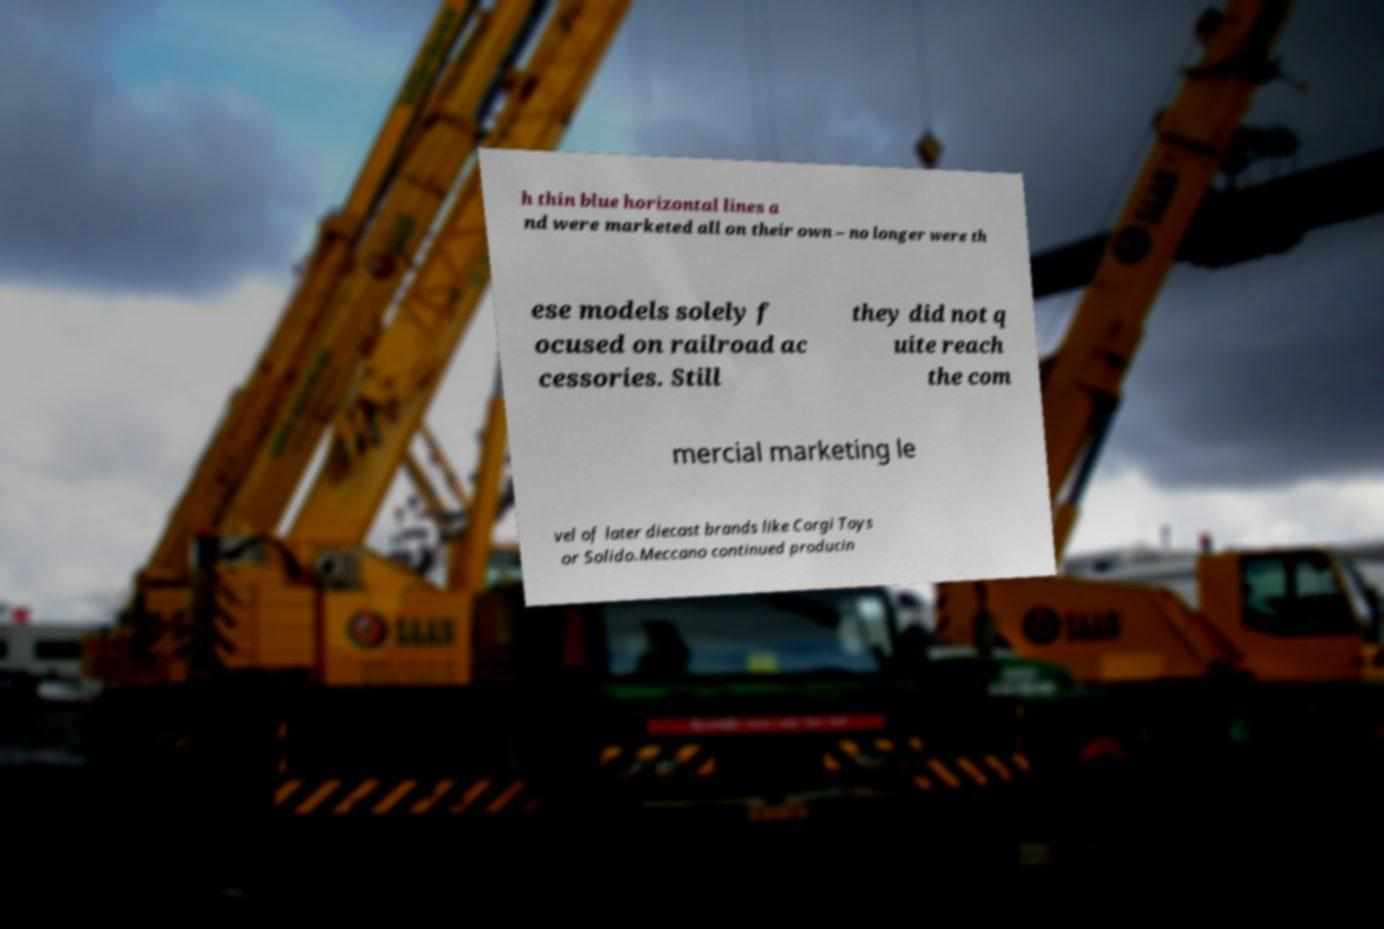Can you read and provide the text displayed in the image?This photo seems to have some interesting text. Can you extract and type it out for me? h thin blue horizontal lines a nd were marketed all on their own – no longer were th ese models solely f ocused on railroad ac cessories. Still they did not q uite reach the com mercial marketing le vel of later diecast brands like Corgi Toys or Solido.Meccano continued producin 